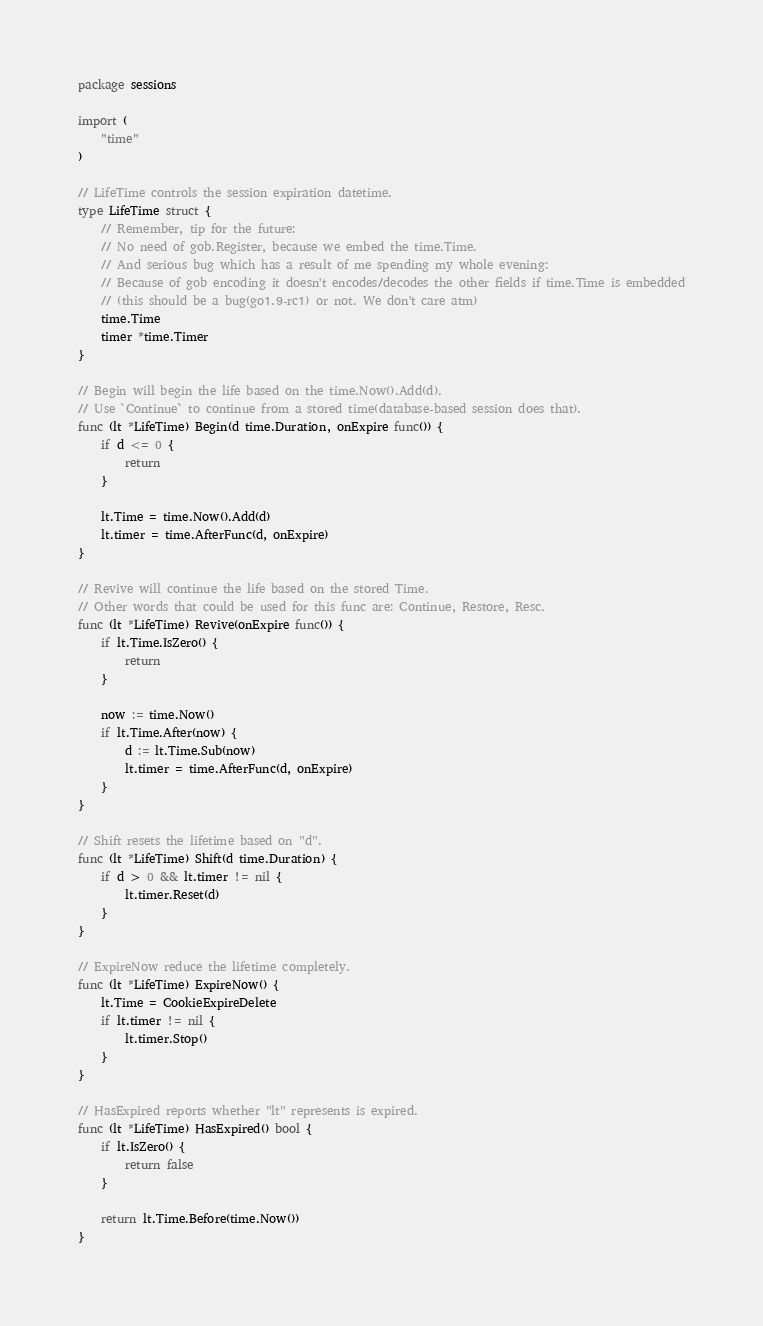Convert code to text. <code><loc_0><loc_0><loc_500><loc_500><_Go_>package sessions

import (
	"time"
)

// LifeTime controls the session expiration datetime.
type LifeTime struct {
	// Remember, tip for the future:
	// No need of gob.Register, because we embed the time.Time.
	// And serious bug which has a result of me spending my whole evening:
	// Because of gob encoding it doesn't encodes/decodes the other fields if time.Time is embedded
	// (this should be a bug(go1.9-rc1) or not. We don't care atm)
	time.Time
	timer *time.Timer
}

// Begin will begin the life based on the time.Now().Add(d).
// Use `Continue` to continue from a stored time(database-based session does that).
func (lt *LifeTime) Begin(d time.Duration, onExpire func()) {
	if d <= 0 {
		return
	}

	lt.Time = time.Now().Add(d)
	lt.timer = time.AfterFunc(d, onExpire)
}

// Revive will continue the life based on the stored Time.
// Other words that could be used for this func are: Continue, Restore, Resc.
func (lt *LifeTime) Revive(onExpire func()) {
	if lt.Time.IsZero() {
		return
	}

	now := time.Now()
	if lt.Time.After(now) {
		d := lt.Time.Sub(now)
		lt.timer = time.AfterFunc(d, onExpire)
	}
}

// Shift resets the lifetime based on "d".
func (lt *LifeTime) Shift(d time.Duration) {
	if d > 0 && lt.timer != nil {
		lt.timer.Reset(d)
	}
}

// ExpireNow reduce the lifetime completely.
func (lt *LifeTime) ExpireNow() {
	lt.Time = CookieExpireDelete
	if lt.timer != nil {
		lt.timer.Stop()
	}
}

// HasExpired reports whether "lt" represents is expired.
func (lt *LifeTime) HasExpired() bool {
	if lt.IsZero() {
		return false
	}

	return lt.Time.Before(time.Now())
}
</code> 